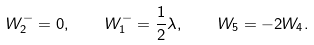Convert formula to latex. <formula><loc_0><loc_0><loc_500><loc_500>W _ { 2 } ^ { - } = 0 , \quad W _ { 1 } ^ { - } = \frac { 1 } { 2 } \lambda , \quad W _ { 5 } = - 2 W _ { 4 } .</formula> 